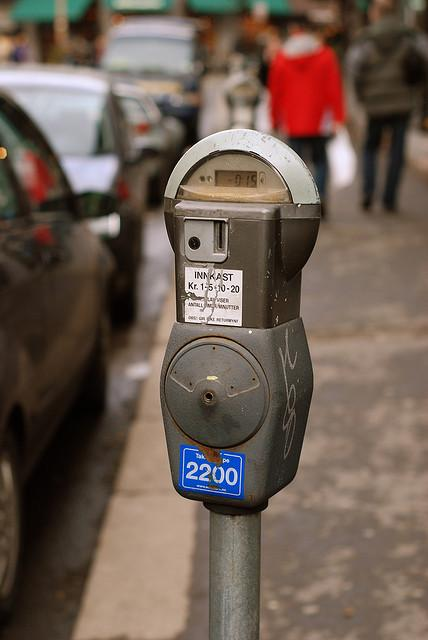What number do you get if you add 10 to the number at the bottom of the meter? 2210 